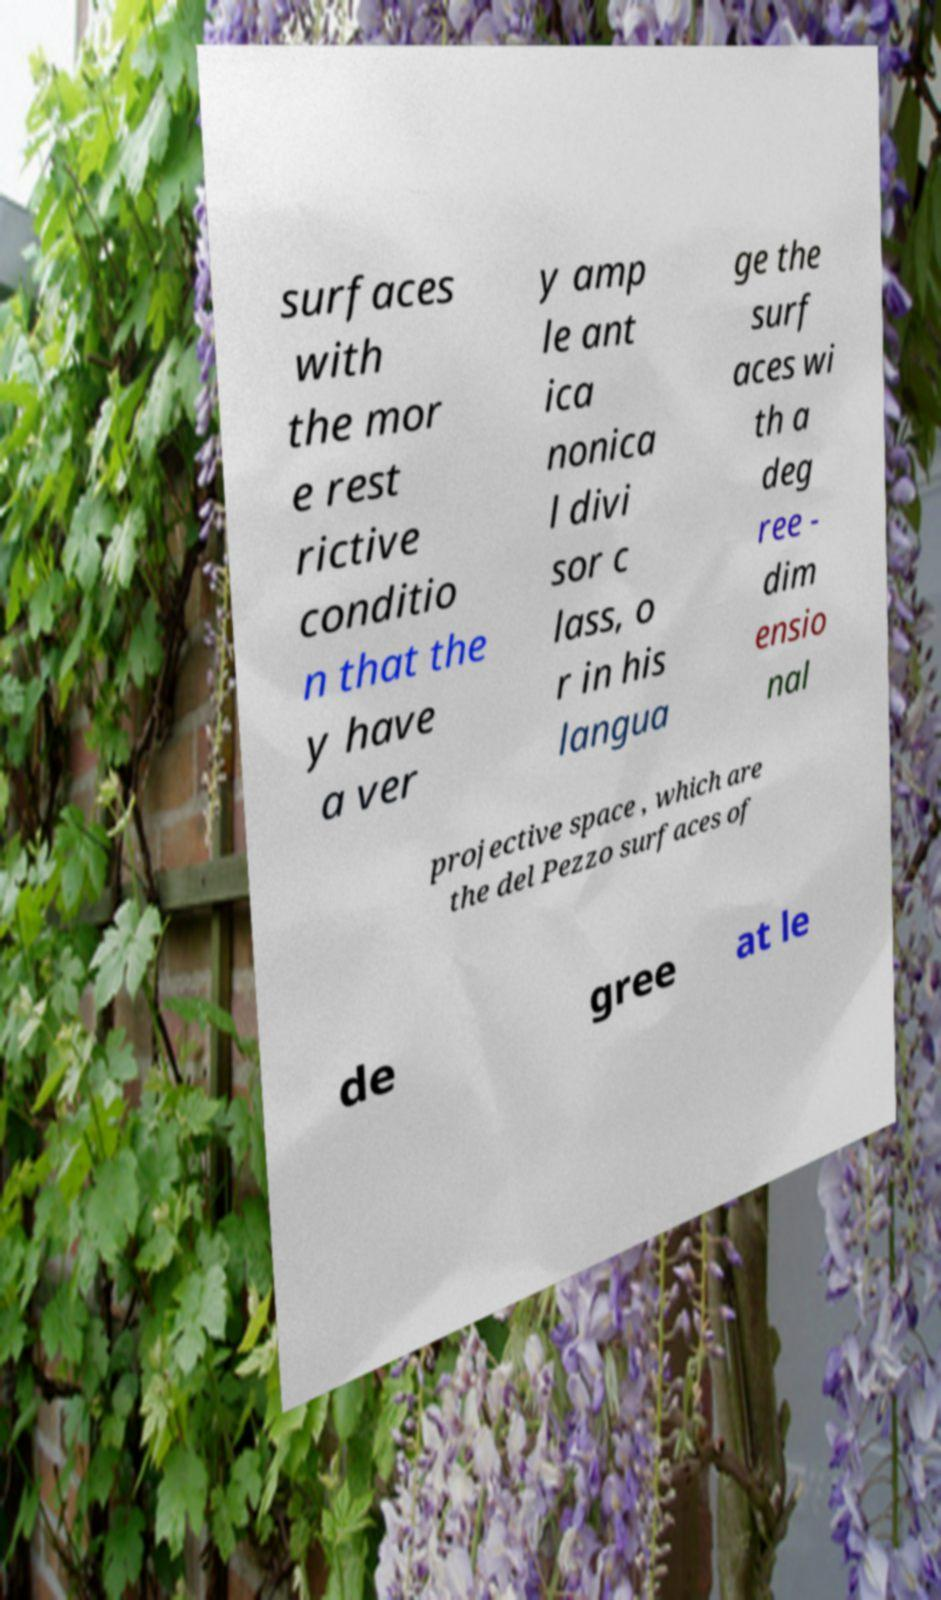Could you extract and type out the text from this image? surfaces with the mor e rest rictive conditio n that the y have a ver y amp le ant ica nonica l divi sor c lass, o r in his langua ge the surf aces wi th a deg ree - dim ensio nal projective space , which are the del Pezzo surfaces of de gree at le 